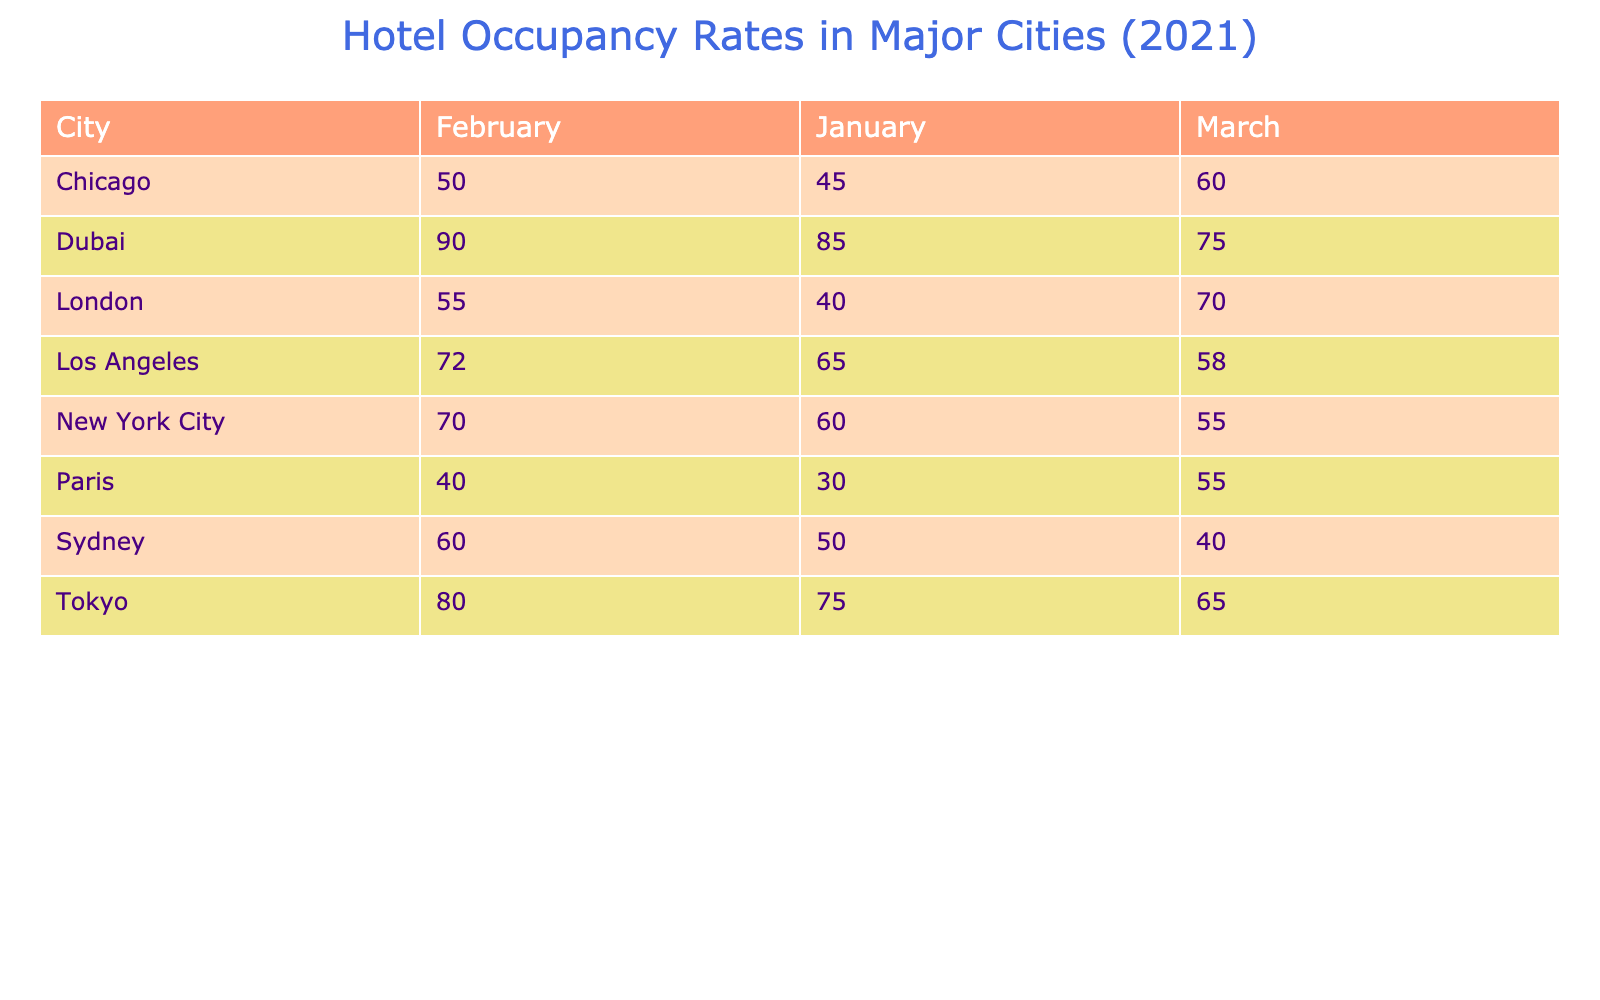What was the highest hotel occupancy rate in Tokyo during the months listed? Looking at the table, the occupancy rates for Tokyo are 75% in January, 80% in February, and 65% in March. The highest of these values is 80%.
Answer: 80% Which city had the lowest average hotel occupancy rate across all three months? To find the city with the lowest average, we calculate the average rates: New York City (60+70+55)/3 = 61.67%, Los Angeles (65+72+58)/3 = 65%, Chicago (45+50+60)/3 = 51.67%, London (40+55+70)/3 = 55%, Tokyo (75+80+65)/3 = 73.33%, Paris (30+40+55)/3 = 41.67%, Dubai (85+90+75)/3 = 83.33%, Sydney (50+60+40)/3 = 50%. The lowest average is for Chicago at 51.67%.
Answer: Chicago Did any hotel in Dubai reach an occupancy rate of 90%? Yes, the Burj Al Arab in Dubai has an occupancy rate of 90% for February.
Answer: Yes What is the difference between the highest and lowest occupancy rates in Sydney? The occupancy rates for Sydney are 50% in January, 60% in February, and 40% in March. The highest value is 60% and the lowest is 40%. The difference is 60% - 40% = 20%.
Answer: 20% Which city had the highest hotel occupancy rate in March 2021? In March, the occupancy rates are as follows: New York City 55%, Los Angeles 58%, Chicago 60%, London 70%, Tokyo 65%, Paris 55%, Dubai 75%, and Sydney 40%. The highest rate is 75% in Dubai.
Answer: Dubai What is the average occupancy rate for hotels in London across the three months? For London, the occupancy rates are 40% in January, 55% in February, and 70% in March. Calculating the average gives: (40+55+70)/3 = 55%.
Answer: 55% Which city had occupancy rates below 50% in any month? Looking at the table, Chicago had 45% in January, and Paris had 30% in January. Both cities had rates below 50% in one or more months.
Answer: Yes By how much did the occupancy rate for the hotel in Los Angeles increase from January to February? The occupancy rates for Los Angeles are 65% in January and 72% in February. The increase is 72% - 65% = 7%.
Answer: 7% For which month did Paris have the highest hotel occupancy rate? In the table for Paris, the rates are 30% in January, 40% in February, and 55% in March. The highest occupancy rate is 55% in March.
Answer: March How many hotels in the dataset had an occupancy rate greater than 75%? The hotels with occupancy rates greater than 75% are: Park Hyatt Tokyo (75%), Shinjuku Granbell Hotel (80%), Atlantis The Palm (85%), Burj Al Arab (90%). That makes it 4 hotels.
Answer: 4 Is the average hotel occupancy rate in February higher than that of March across all cities? The averages for February are calculated as follows: (70+72+50+55+80+40+90+60) = 66.25%. For March: (55+58+60+70+65+55+75+40) = 60%. Since 66.25% > 60%, February's average is indeed higher.
Answer: Yes 